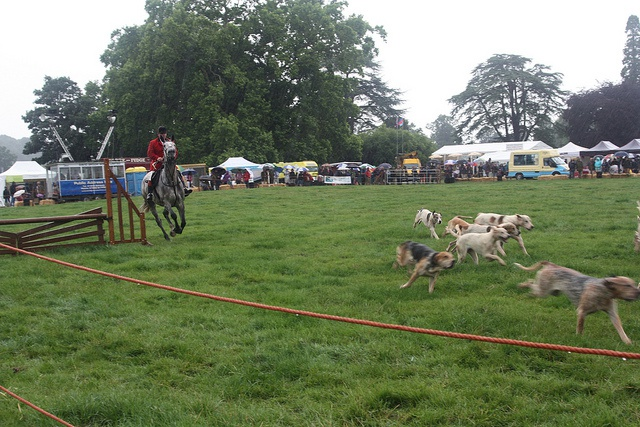Describe the objects in this image and their specific colors. I can see dog in white, gray, and darkgreen tones, bus in white, gray, darkgray, black, and blue tones, horse in white, black, gray, darkgray, and darkgreen tones, dog in white, gray, darkgreen, and black tones, and bus in white, tan, gray, darkgray, and ivory tones in this image. 